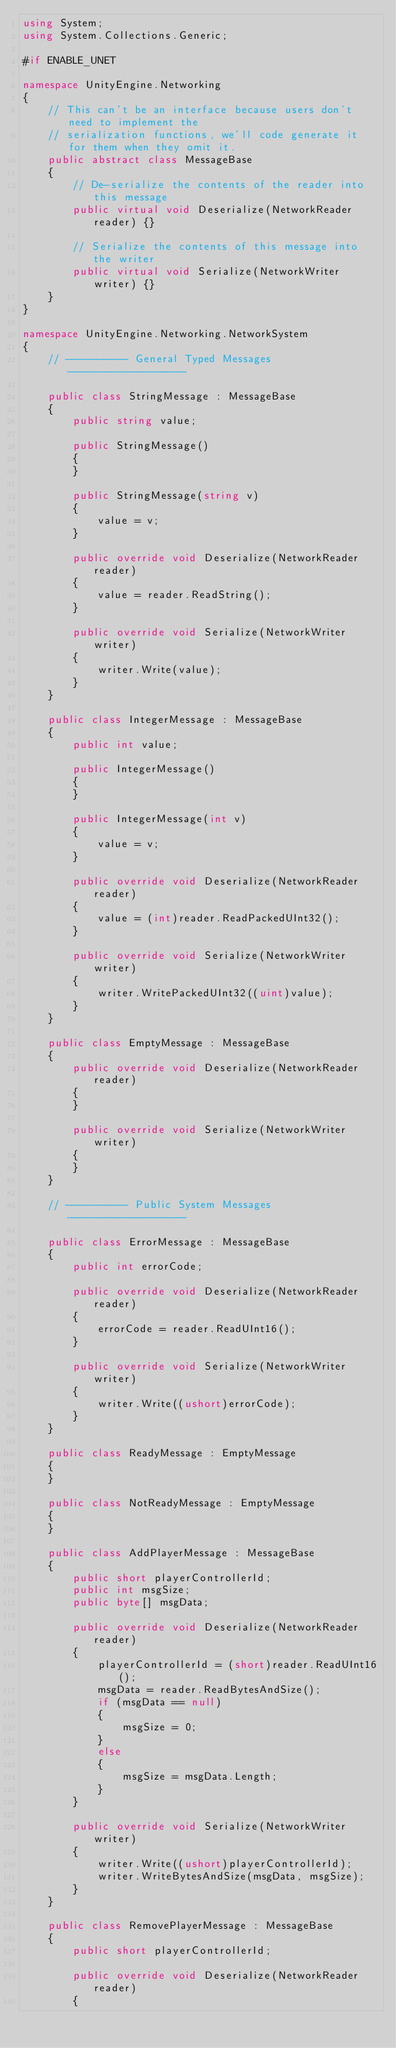Convert code to text. <code><loc_0><loc_0><loc_500><loc_500><_C#_>using System;
using System.Collections.Generic;

#if ENABLE_UNET

namespace UnityEngine.Networking
{
    // This can't be an interface because users don't need to implement the
    // serialization functions, we'll code generate it for them when they omit it.
    public abstract class MessageBase
    {
        // De-serialize the contents of the reader into this message
        public virtual void Deserialize(NetworkReader reader) {}

        // Serialize the contents of this message into the writer
        public virtual void Serialize(NetworkWriter writer) {}
    }
}

namespace UnityEngine.Networking.NetworkSystem
{
    // ---------- General Typed Messages -------------------

    public class StringMessage : MessageBase
    {
        public string value;

        public StringMessage()
        {
        }

        public StringMessage(string v)
        {
            value = v;
        }

        public override void Deserialize(NetworkReader reader)
        {
            value = reader.ReadString();
        }

        public override void Serialize(NetworkWriter writer)
        {
            writer.Write(value);
        }
    }

    public class IntegerMessage : MessageBase
    {
        public int value;

        public IntegerMessage()
        {
        }

        public IntegerMessage(int v)
        {
            value = v;
        }

        public override void Deserialize(NetworkReader reader)
        {
            value = (int)reader.ReadPackedUInt32();
        }

        public override void Serialize(NetworkWriter writer)
        {
            writer.WritePackedUInt32((uint)value);
        }
    }

    public class EmptyMessage : MessageBase
    {
        public override void Deserialize(NetworkReader reader)
        {
        }

        public override void Serialize(NetworkWriter writer)
        {
        }
    }

    // ---------- Public System Messages -------------------

    public class ErrorMessage : MessageBase
    {
        public int errorCode;

        public override void Deserialize(NetworkReader reader)
        {
            errorCode = reader.ReadUInt16();
        }

        public override void Serialize(NetworkWriter writer)
        {
            writer.Write((ushort)errorCode);
        }
    }

    public class ReadyMessage : EmptyMessage
    {
    }

    public class NotReadyMessage : EmptyMessage
    {
    }

    public class AddPlayerMessage : MessageBase
    {
        public short playerControllerId;
        public int msgSize;
        public byte[] msgData;

        public override void Deserialize(NetworkReader reader)
        {
            playerControllerId = (short)reader.ReadUInt16();
            msgData = reader.ReadBytesAndSize();
            if (msgData == null)
            {
                msgSize = 0;
            }
            else
            {
                msgSize = msgData.Length;
            }
        }

        public override void Serialize(NetworkWriter writer)
        {
            writer.Write((ushort)playerControllerId);
            writer.WriteBytesAndSize(msgData, msgSize);
        }
    }

    public class RemovePlayerMessage : MessageBase
    {
        public short playerControllerId;

        public override void Deserialize(NetworkReader reader)
        {</code> 